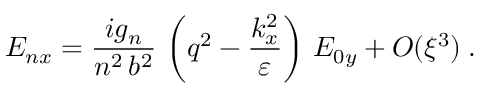<formula> <loc_0><loc_0><loc_500><loc_500>E _ { n x } = \frac { i g _ { n } } { n ^ { 2 } \, b ^ { 2 } } \, \left ( q ^ { 2 } - \frac { k _ { x } ^ { 2 } } { \varepsilon } \right ) \, E _ { 0 y } + O ( \xi ^ { 3 } ) \, .</formula> 